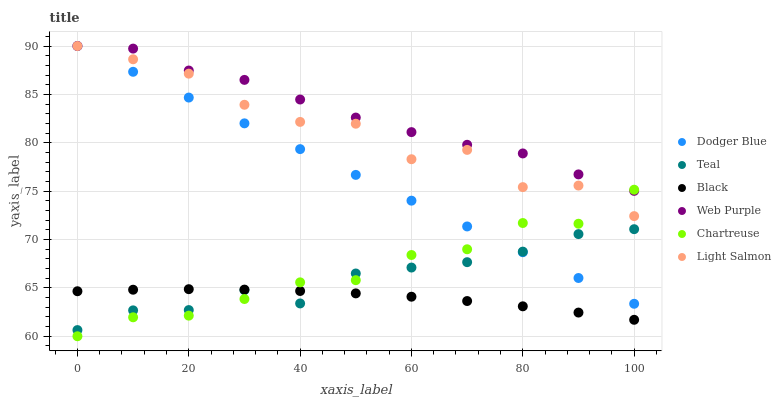Does Black have the minimum area under the curve?
Answer yes or no. Yes. Does Web Purple have the maximum area under the curve?
Answer yes or no. Yes. Does Chartreuse have the minimum area under the curve?
Answer yes or no. No. Does Chartreuse have the maximum area under the curve?
Answer yes or no. No. Is Dodger Blue the smoothest?
Answer yes or no. Yes. Is Light Salmon the roughest?
Answer yes or no. Yes. Is Chartreuse the smoothest?
Answer yes or no. No. Is Chartreuse the roughest?
Answer yes or no. No. Does Chartreuse have the lowest value?
Answer yes or no. Yes. Does Web Purple have the lowest value?
Answer yes or no. No. Does Dodger Blue have the highest value?
Answer yes or no. Yes. Does Chartreuse have the highest value?
Answer yes or no. No. Is Teal less than Light Salmon?
Answer yes or no. Yes. Is Light Salmon greater than Black?
Answer yes or no. Yes. Does Chartreuse intersect Light Salmon?
Answer yes or no. Yes. Is Chartreuse less than Light Salmon?
Answer yes or no. No. Is Chartreuse greater than Light Salmon?
Answer yes or no. No. Does Teal intersect Light Salmon?
Answer yes or no. No. 